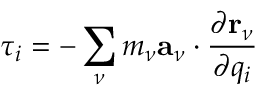<formula> <loc_0><loc_0><loc_500><loc_500>\tau _ { i } = - \sum _ { \nu } m _ { \nu } a _ { \nu } \cdot \frac { \partial r _ { \nu } } { \partial q _ { i } }</formula> 